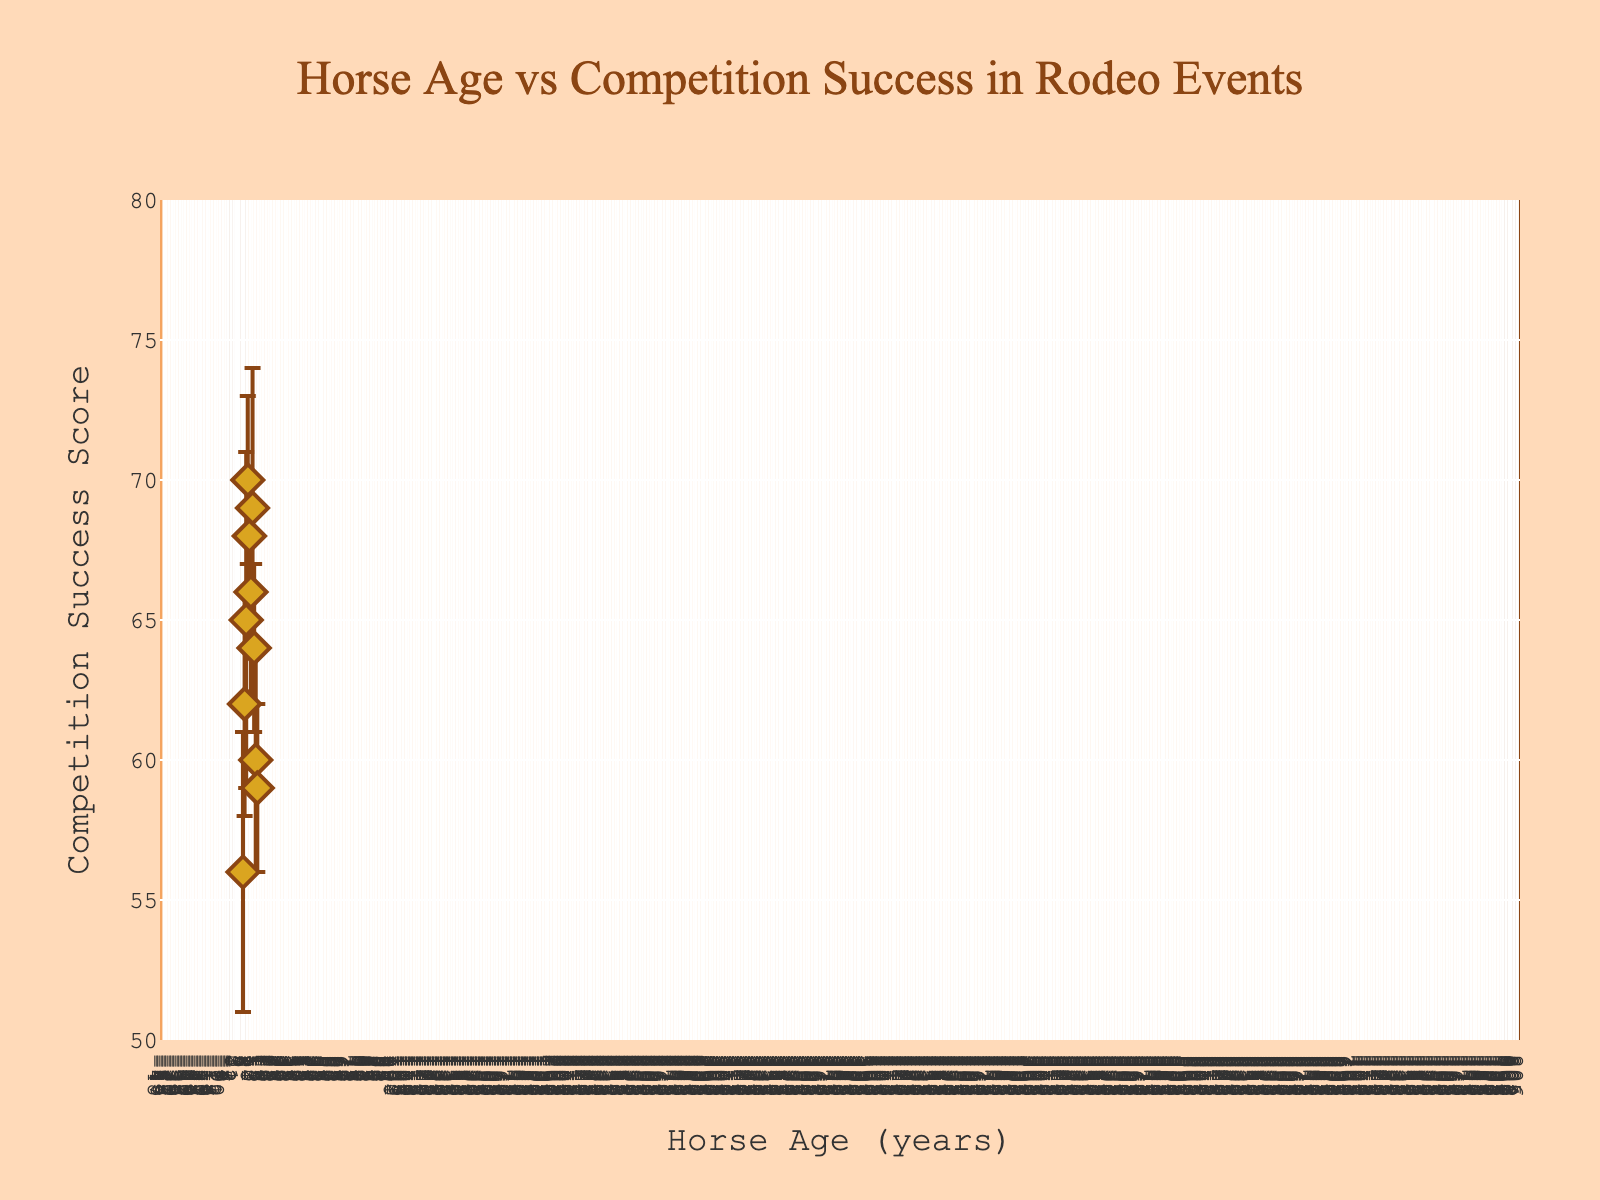Which age group of horses has the highest competition success? By inspecting the scatter plot, the highest competition success data point is around age 7, with a value of 70.
Answer: Age 7 How many data points are plotted on the graph? Count the number of markers on the graph. There are markers for ages 4 through 13, so there are 10 data points.
Answer: 10 What's the average competition success score of horses aged 10 and above? For horses aged 10, 11, 12, and 13: The respective scores are 69, 64, 60, and 59. Sum these values (69 + 64 + 60 + 59 = 252) and then divide by 4 (252 / 4).
Answer: 63 Which horse age has the greatest uncertainty estimate? Referring to the error bars, the largest uncertainty bar length pertains to the horses aged 6 and 10, with uncertainty values of 6 and 5.
Answer: Age 6 What is the range of competition success scores? The highest score is 70 (age 7), and the lowest score is 56 (age 4). The range is calculated as the difference between the two values (70 - 56).
Answer: 14 For horses aged 8, 9, and 10, which has the lowest competition success score? Referring to the plot, the scores are 68, 66, and 69 respectively. The lowest score among these is at age 9.
Answer: Age 9 What is the overall trend of competition success as horse age increases? Inspecting the scatter plot, competition success generally increases from age 4 to 7, peaks around age 7, then starts to decrease slowly until age 13.
Answer: Increases then decreases How does the competition success at age 6 compare to that at age 12? The competition success at age 6 is 65, while at age 12 it is 60. Thus, the success at age 6 is higher.
Answer: Age 6 is higher Is there any age where the competition success score significantly decreases compared to its previous age? From the plot, comparing each consecutive pair of points, the score from age 11 (64) to age 12 (60) shows a significant decrease of 4 points.
Answer: Between ages 11 and 12 What is the general color palette and visual style of the plot? The scatter plot is created mainly with shades of brown and gold, featuring diamond markers with brown borderlines, resembling western aesthetics. The plot background is sandy-colored, augmented with a styled lasso rope border.
Answer: Brown and gold 